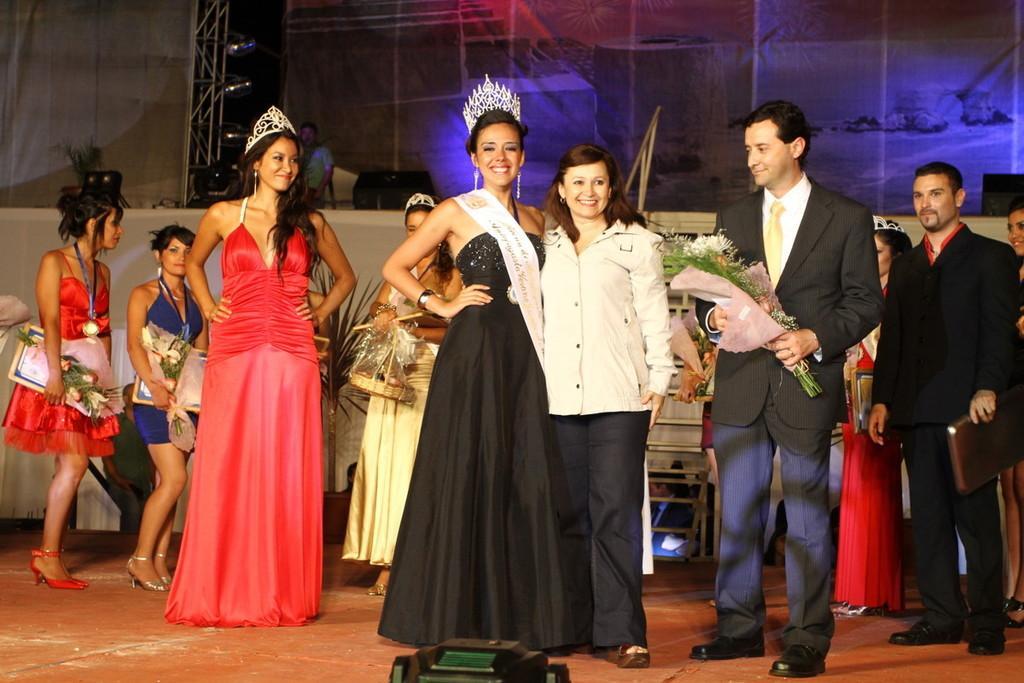Could you give a brief overview of what you see in this image? In this image there are a group of people who are standing, and some of them are wearing crowns and holding flower bouquets. And at the bottom there is stage and some object, and in the background there are some objects, pole, tower, light and some objects, light and plant. 